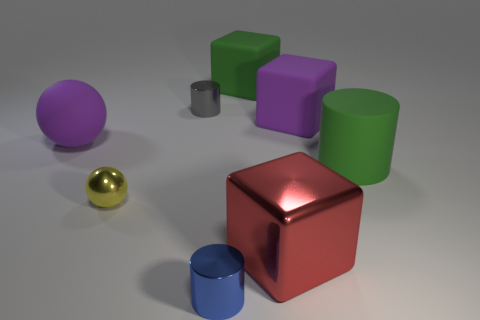How many objects in total can be seen in the image? In total, there are eight objects visible in the image. This includes a mix of cubes, cylinders, and spheres, each with different colors and materials. 